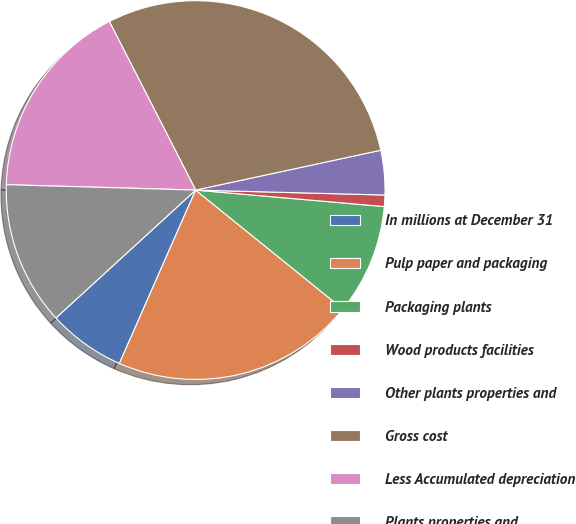Convert chart. <chart><loc_0><loc_0><loc_500><loc_500><pie_chart><fcel>In millions at December 31<fcel>Pulp paper and packaging<fcel>Packaging plants<fcel>Wood products facilities<fcel>Other plants properties and<fcel>Gross cost<fcel>Less Accumulated depreciation<fcel>Plants properties and<nl><fcel>6.61%<fcel>20.78%<fcel>9.43%<fcel>0.97%<fcel>3.79%<fcel>29.16%<fcel>17.02%<fcel>12.25%<nl></chart> 